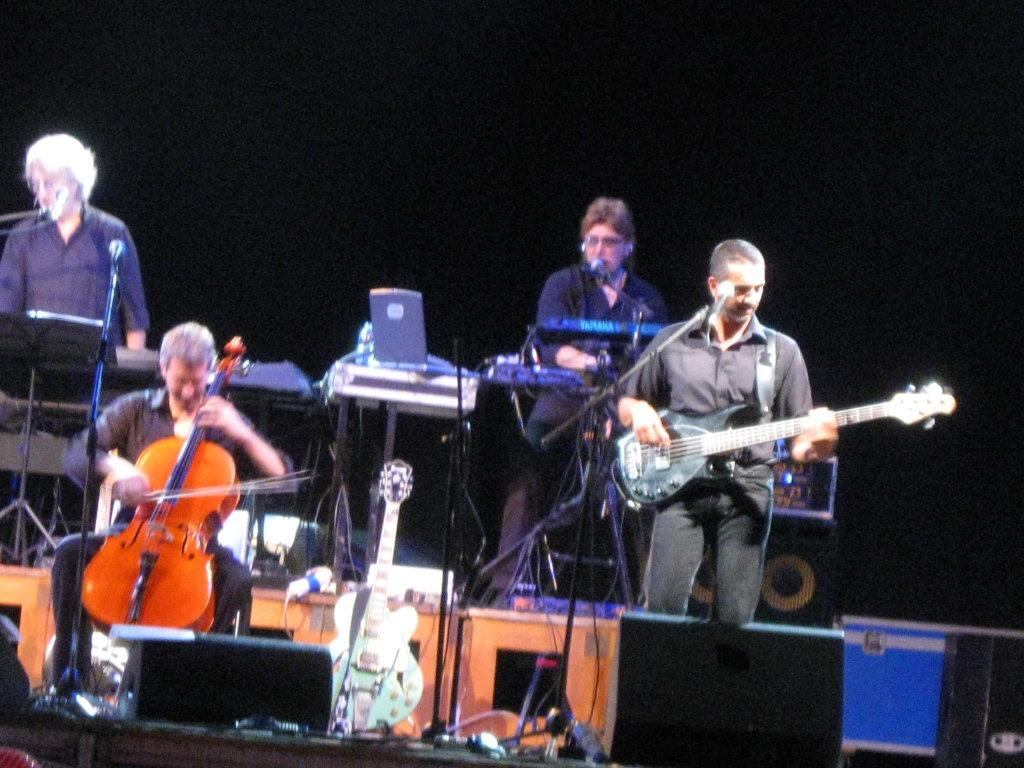What is happening in the image? There is a band of musicians performing in the image. Where are the musicians performing? The musicians are performing on a stage. What type of mist can be seen surrounding the musicians on stage? There is no mist present in the image; the musicians are performing on a stage without any visible mist. 